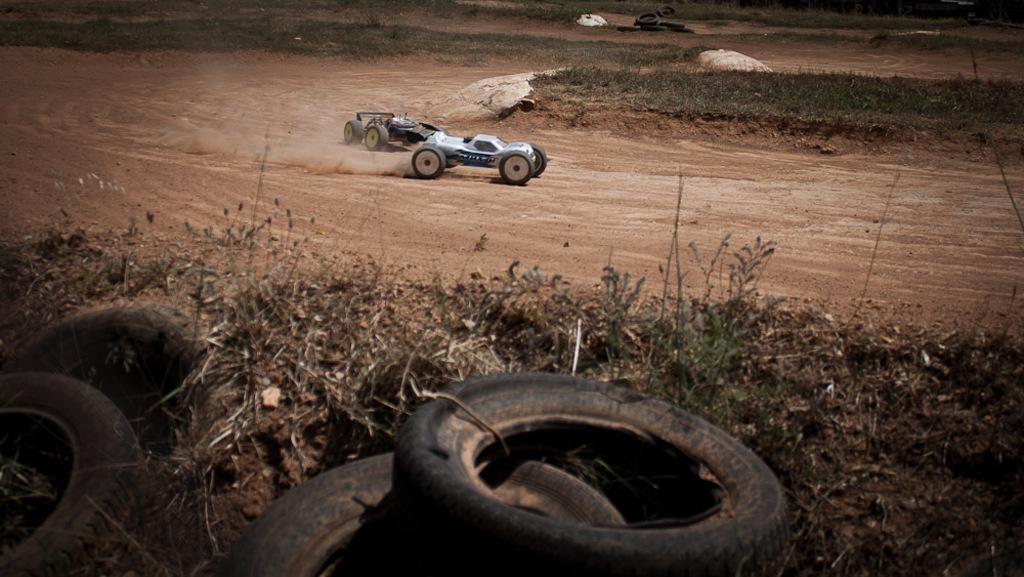What type of ground can be seen in the image? The ground in the image is sandy. How many vehicles are present in the image? There are two vehicles on the sand ground. Where are the tires located in the image? There are tires in the left corner of the image, and other tires are visible as well. What can be seen in the background of the image? There is a greenery ground in the background of the image. What sense is being stimulated by the line in the image? There is no line present in the image, so it is not possible to determine which sense might be stimulated. 